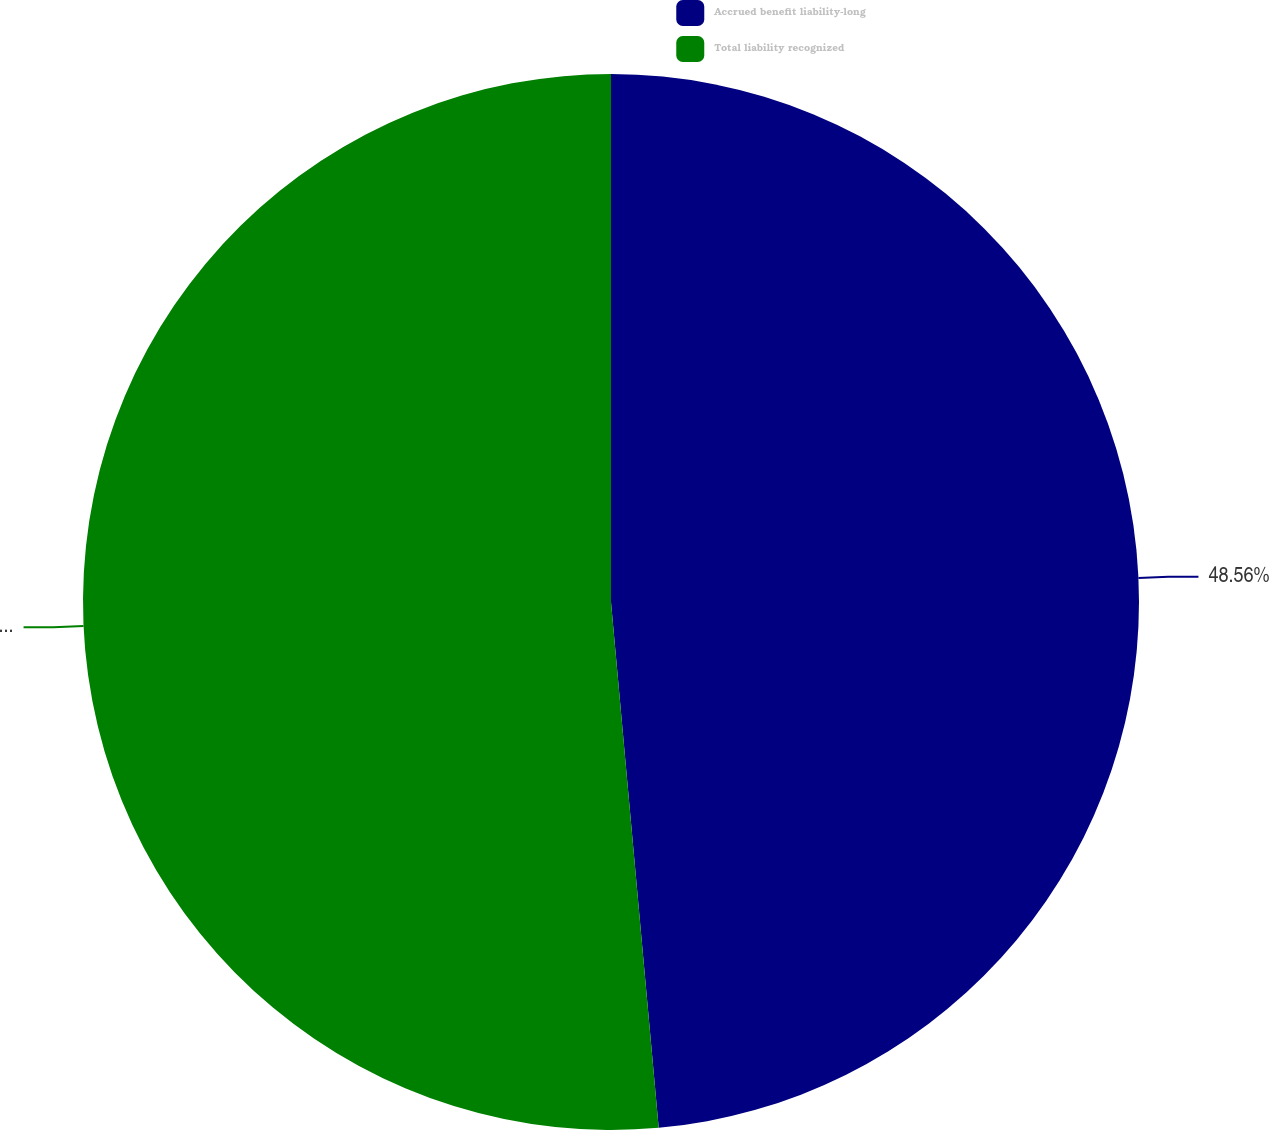Convert chart. <chart><loc_0><loc_0><loc_500><loc_500><pie_chart><fcel>Accrued benefit liability-long<fcel>Total liability recognized<nl><fcel>48.56%<fcel>51.44%<nl></chart> 